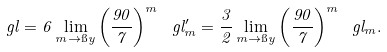<formula> <loc_0><loc_0><loc_500><loc_500>\ g l = 6 \lim _ { m \to \i y } \left ( \frac { 9 0 } { 7 } \right ) ^ { m } \ g l _ { m } ^ { \prime } = \frac { 3 } { 2 } \lim _ { m \to \i y } \left ( \frac { 9 0 } { 7 } \right ) ^ { m } \ g l _ { m } .</formula> 